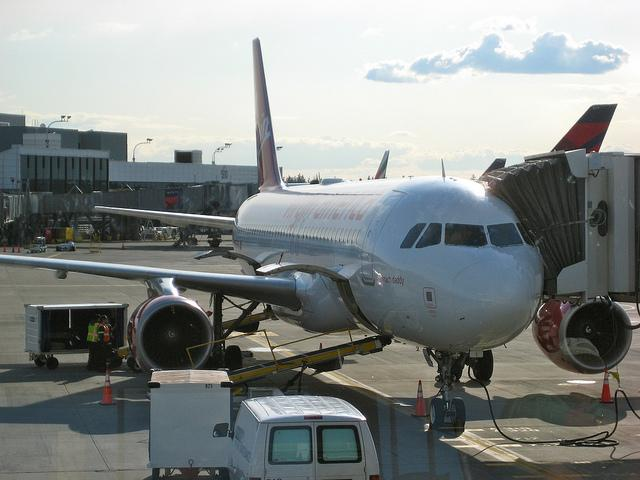Who created the first successful vehicle of this type? wright brothers 